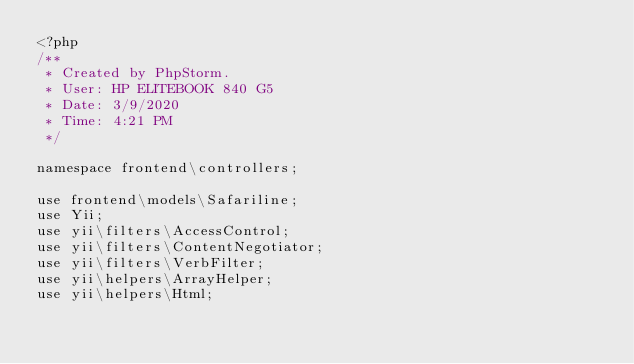<code> <loc_0><loc_0><loc_500><loc_500><_PHP_><?php
/**
 * Created by PhpStorm.
 * User: HP ELITEBOOK 840 G5
 * Date: 3/9/2020
 * Time: 4:21 PM
 */

namespace frontend\controllers;

use frontend\models\Safariline;
use Yii;
use yii\filters\AccessControl;
use yii\filters\ContentNegotiator;
use yii\filters\VerbFilter;
use yii\helpers\ArrayHelper;
use yii\helpers\Html;</code> 